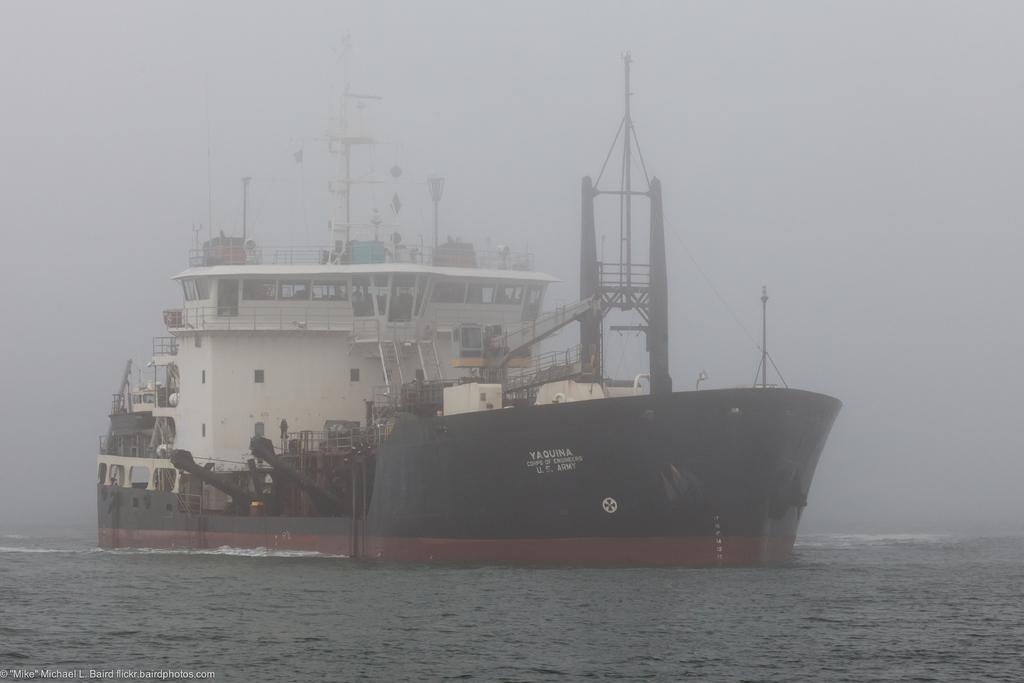What is the main subject of the image? The main subject of the image is a ship. Where is the ship located in the image? The ship is sailing on the sea in the image. What can be found inside the ship? There are different equipment inside the ship. How would you describe the weather in the image? The climate in the image is cool with fog. What type of yarn is being sold in the shop on the ship? There is no shop or yarn present in the image; it features a ship sailing on the sea with cool, foggy weather. 